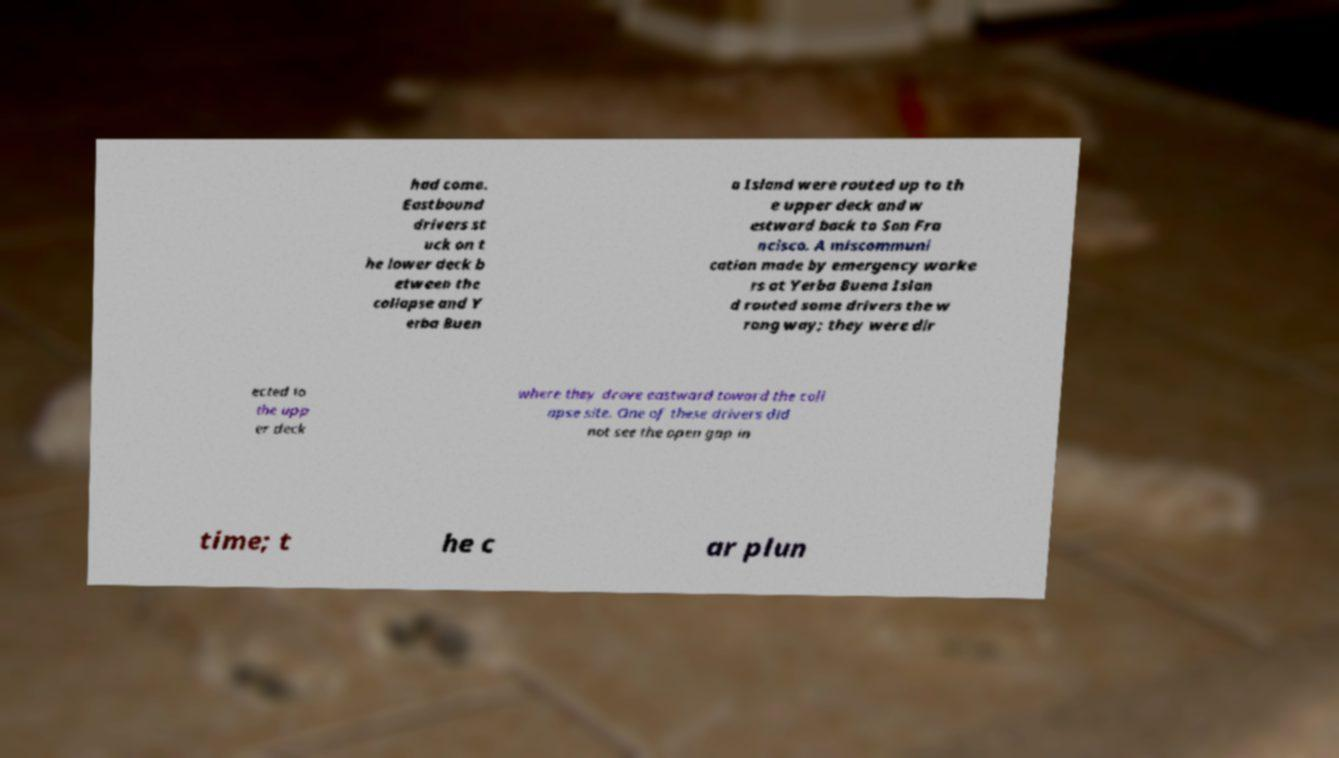Please read and relay the text visible in this image. What does it say? had come. Eastbound drivers st uck on t he lower deck b etween the collapse and Y erba Buen a Island were routed up to th e upper deck and w estward back to San Fra ncisco. A miscommuni cation made by emergency worke rs at Yerba Buena Islan d routed some drivers the w rong way; they were dir ected to the upp er deck where they drove eastward toward the coll apse site. One of these drivers did not see the open gap in time; t he c ar plun 